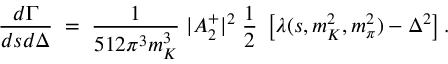Convert formula to latex. <formula><loc_0><loc_0><loc_500><loc_500>\frac { d \Gamma } { d s d \Delta } \, = \, \frac { 1 } { 5 1 2 \pi ^ { 3 } m _ { K } ^ { 3 } } \, | A _ { 2 } ^ { + } | ^ { 2 } \, \frac { 1 } { 2 } \, \left [ \lambda ( s , m _ { K } ^ { 2 } , m _ { \pi } ^ { 2 } ) - \Delta ^ { 2 } \right ] .</formula> 